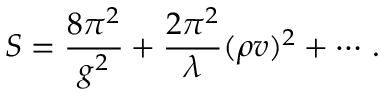<formula> <loc_0><loc_0><loc_500><loc_500>S = \frac { 8 \pi ^ { 2 } } { g ^ { 2 } } + \frac { 2 \pi ^ { 2 } } { \lambda } ( \rho v ) ^ { 2 } + \cdots \, .</formula> 